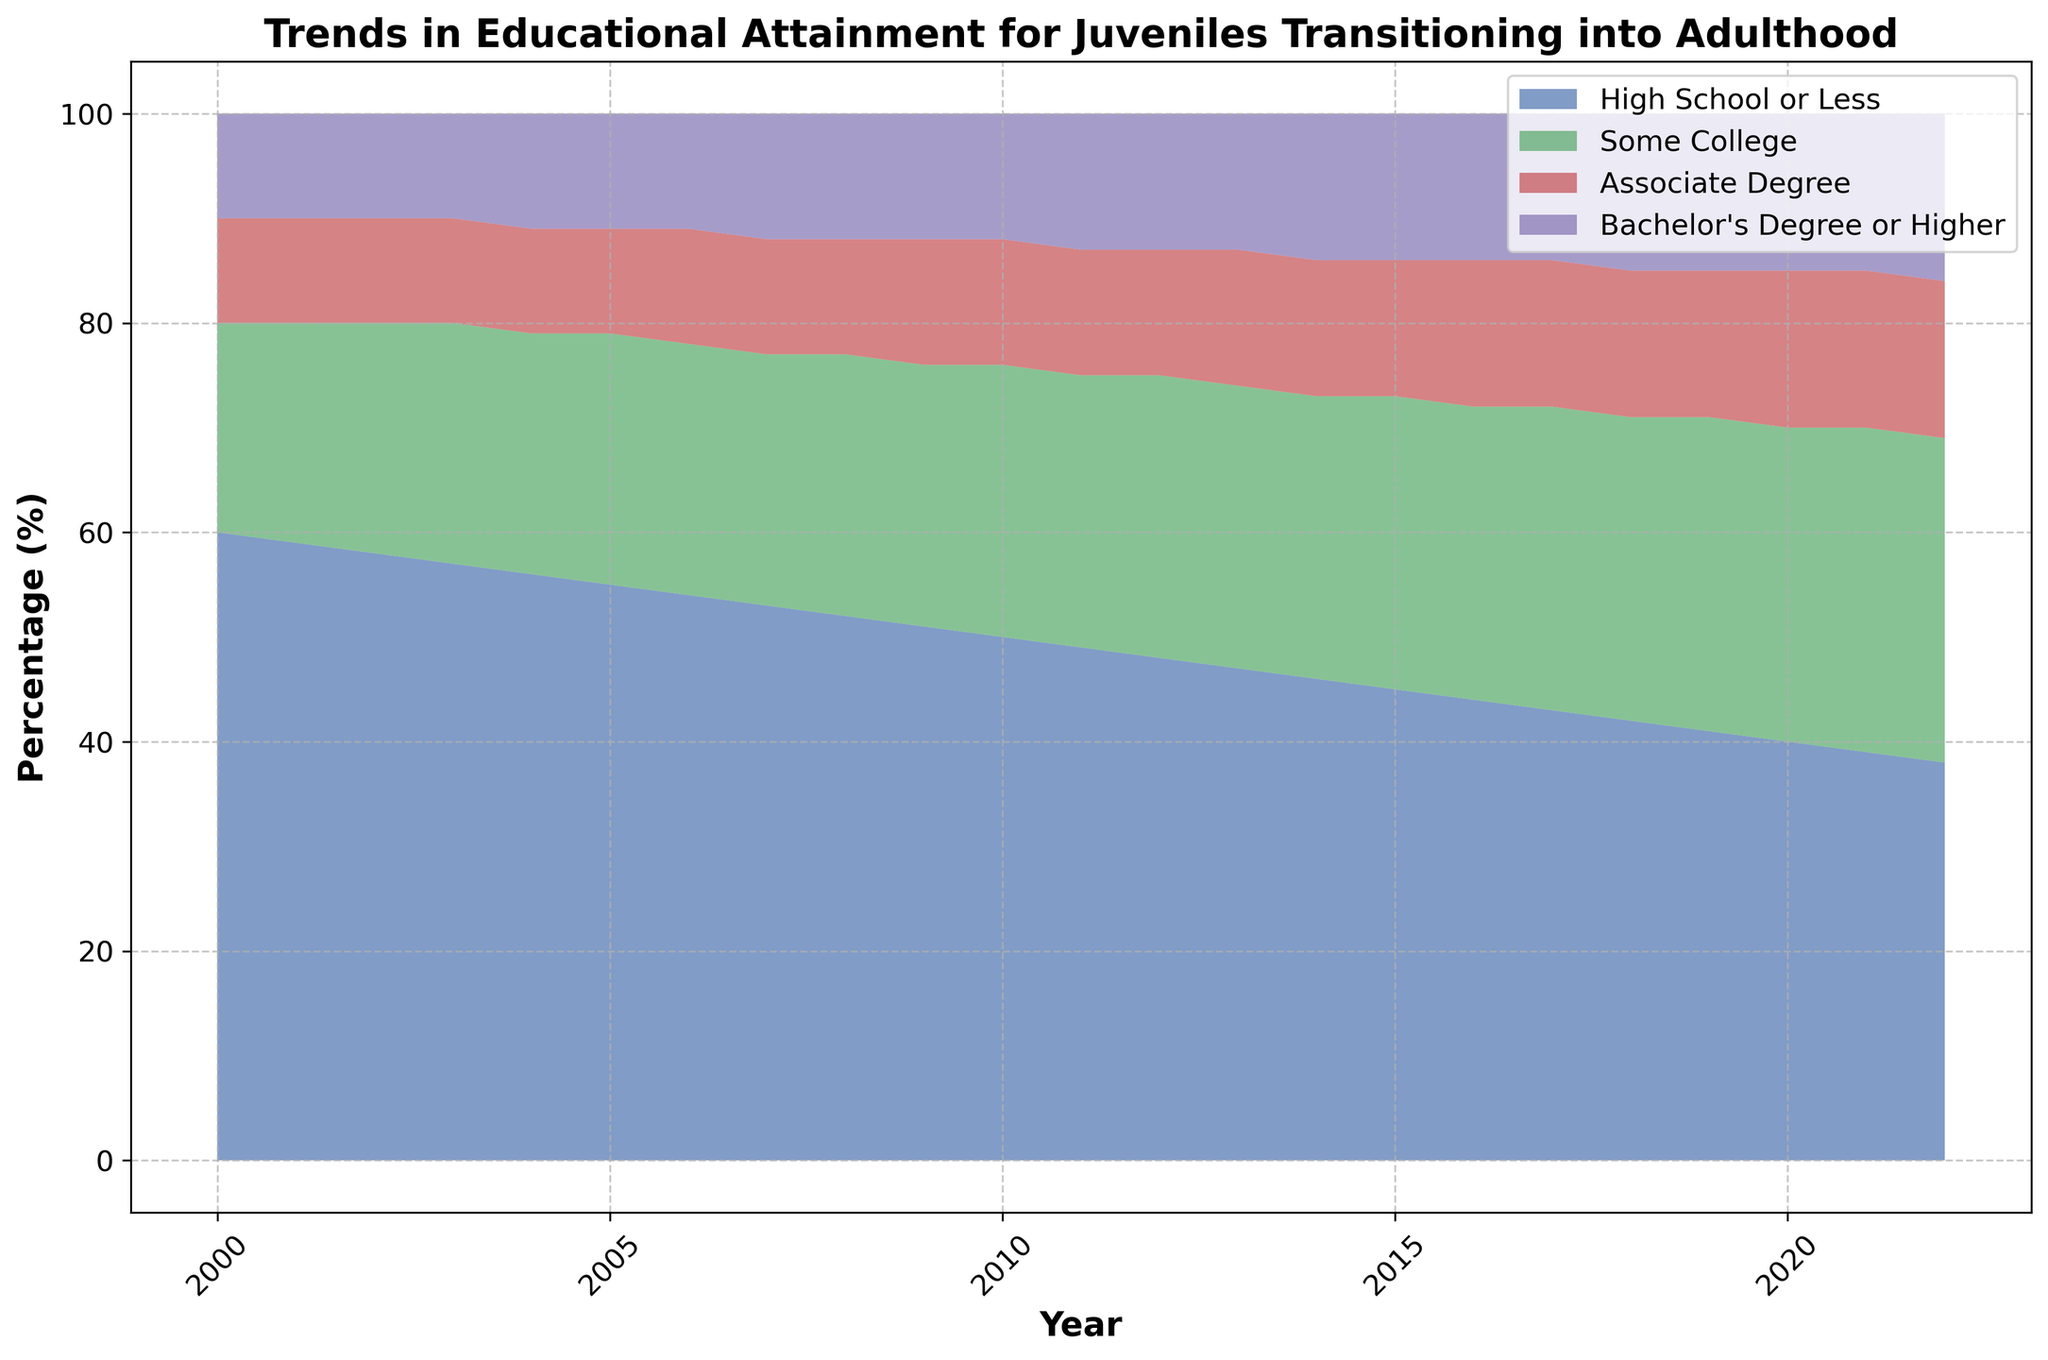Which category saw the largest decrease in percentage over the years? To identify the largest decrease, we can compare the difference in percentage from the first year (2000) to the last year (2022) for each category. "High School or Less" decreased from 60% to 38%, which is a 22% decrease, the largest among all categories.
Answer: High School or Less As of 2022, which educational attainment category comprises the smallest percentage? In 2022, the categories are "High School or Less" (38%), "Some College" (31%), "Associate Degree" (15%), and "Bachelor's Degree or Higher" (16%). The smallest percentage is "Associate Degree" at 15%.
Answer: Associate Degree What has been the trend for "Some College" over the years? By visual inspection of the plot, the area representing "Some College" has increased over time, starting from 20% in 2000 and reaching 31% in 2022.
Answer: Increasing In which year did "Bachelor’s Degree or Higher" first surpass 10%? To find this, we can track the "Bachelor’s Degree or Higher" area over the years. It first surpasses 10% in 2004, where it reaches 11%.
Answer: 2004 How much did the percentage of "High School or Less" change from 2000 to 2010? The initial percentage in 2000 was 60%, and in 2010 it was 50%. The change is calculated as 60% - 50% = 10%.
Answer: 10% Which educational attainment category remained the most stable over the years? Observing the trends in the plot, the "Associate Degree" area seems to remain the most stable, starting close to 10% and ending at 15%, with only minor fluctuations.
Answer: Associate Degree What is the total percentage combined for "Associate Degree" and "Bachelor's Degree or Higher" in 2015? We need to add the percentages for "Associate Degree" (13%) and "Bachelor's Degree or Higher" (14%) in 2015. 13% + 14% = 27%.
Answer: 27% By how much did "Some College" increase from 2008 to 2022? In 2008, "Some College" was 25%, and in 2022 it reached 31%. The increase is 31% - 25% = 6%.
Answer: 6% Is the overall trend of educational attainment levels increasing or decreasing over the years? Observing the plot, we see that higher education categories ("Associate Degree" and "Bachelor's Degree or Higher") have generally increased, implying an overall increase in education levels.
Answer: Increasing 